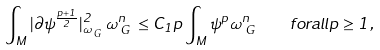Convert formula to latex. <formula><loc_0><loc_0><loc_500><loc_500>\int _ { M } | \partial \psi ^ { \frac { p + 1 } { 2 } } | _ { \omega _ { \emph { G } } } ^ { 2 } \omega _ { \emph { G } } ^ { n } \leq C _ { 1 } p \int _ { M } \psi ^ { p } \omega _ { \emph { G } } ^ { n } \quad f o r a l l p \geq 1 ,</formula> 